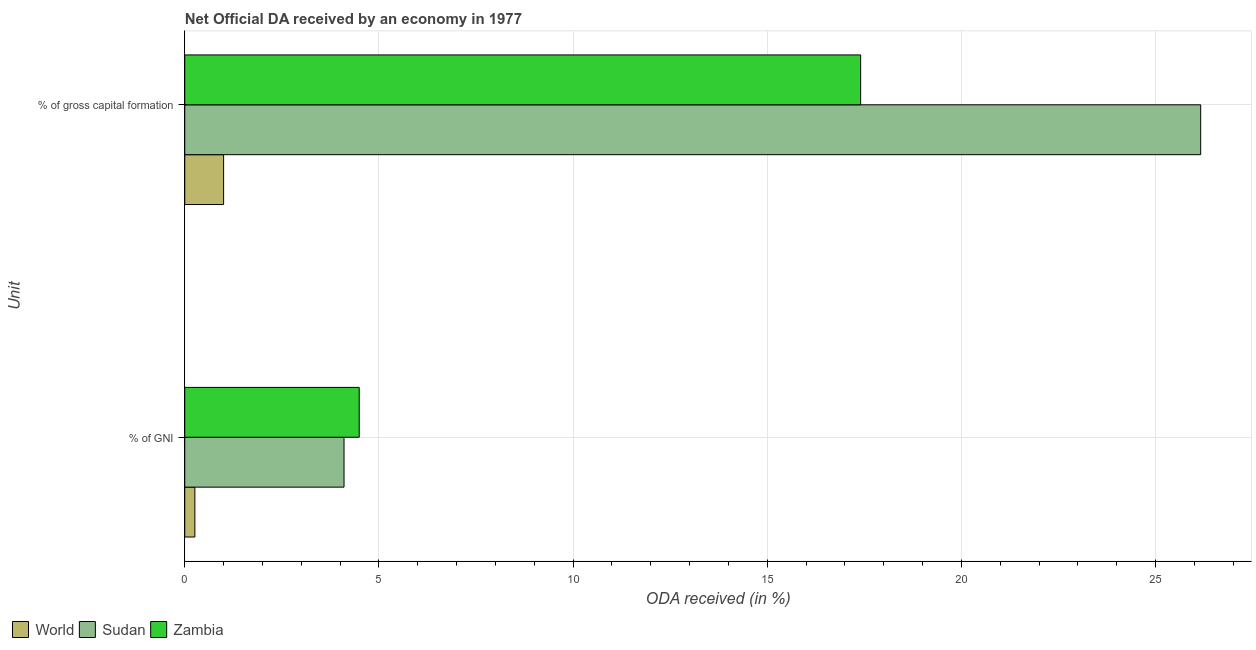How many groups of bars are there?
Your answer should be compact. 2. Are the number of bars on each tick of the Y-axis equal?
Give a very brief answer. Yes. How many bars are there on the 2nd tick from the top?
Ensure brevity in your answer.  3. How many bars are there on the 2nd tick from the bottom?
Your response must be concise. 3. What is the label of the 2nd group of bars from the top?
Provide a short and direct response. % of GNI. What is the oda received as percentage of gross capital formation in Zambia?
Provide a succinct answer. 17.4. Across all countries, what is the maximum oda received as percentage of gni?
Provide a succinct answer. 4.49. Across all countries, what is the minimum oda received as percentage of gross capital formation?
Offer a terse response. 1. In which country was the oda received as percentage of gni maximum?
Provide a succinct answer. Zambia. In which country was the oda received as percentage of gni minimum?
Your answer should be very brief. World. What is the total oda received as percentage of gross capital formation in the graph?
Provide a succinct answer. 44.57. What is the difference between the oda received as percentage of gni in Zambia and that in World?
Your answer should be compact. 4.23. What is the difference between the oda received as percentage of gross capital formation in World and the oda received as percentage of gni in Sudan?
Your answer should be very brief. -3.1. What is the average oda received as percentage of gni per country?
Your response must be concise. 2.95. What is the difference between the oda received as percentage of gni and oda received as percentage of gross capital formation in Zambia?
Offer a very short reply. -12.91. In how many countries, is the oda received as percentage of gross capital formation greater than 14 %?
Offer a very short reply. 2. What is the ratio of the oda received as percentage of gni in Sudan to that in World?
Provide a succinct answer. 15.73. In how many countries, is the oda received as percentage of gross capital formation greater than the average oda received as percentage of gross capital formation taken over all countries?
Keep it short and to the point. 2. What does the 3rd bar from the bottom in % of GNI represents?
Offer a very short reply. Zambia. How many countries are there in the graph?
Your response must be concise. 3. What is the difference between two consecutive major ticks on the X-axis?
Your answer should be compact. 5. Are the values on the major ticks of X-axis written in scientific E-notation?
Provide a short and direct response. No. Does the graph contain any zero values?
Ensure brevity in your answer.  No. How many legend labels are there?
Provide a succinct answer. 3. How are the legend labels stacked?
Make the answer very short. Horizontal. What is the title of the graph?
Ensure brevity in your answer.  Net Official DA received by an economy in 1977. Does "Samoa" appear as one of the legend labels in the graph?
Provide a short and direct response. No. What is the label or title of the X-axis?
Give a very brief answer. ODA received (in %). What is the label or title of the Y-axis?
Provide a short and direct response. Unit. What is the ODA received (in %) in World in % of GNI?
Your answer should be compact. 0.26. What is the ODA received (in %) in Sudan in % of GNI?
Provide a succinct answer. 4.1. What is the ODA received (in %) in Zambia in % of GNI?
Offer a very short reply. 4.49. What is the ODA received (in %) of World in % of gross capital formation?
Offer a terse response. 1. What is the ODA received (in %) in Sudan in % of gross capital formation?
Make the answer very short. 26.16. What is the ODA received (in %) of Zambia in % of gross capital formation?
Keep it short and to the point. 17.4. Across all Unit, what is the maximum ODA received (in %) of World?
Your response must be concise. 1. Across all Unit, what is the maximum ODA received (in %) in Sudan?
Your answer should be very brief. 26.16. Across all Unit, what is the maximum ODA received (in %) of Zambia?
Offer a terse response. 17.4. Across all Unit, what is the minimum ODA received (in %) of World?
Ensure brevity in your answer.  0.26. Across all Unit, what is the minimum ODA received (in %) in Sudan?
Your answer should be compact. 4.1. Across all Unit, what is the minimum ODA received (in %) of Zambia?
Offer a terse response. 4.49. What is the total ODA received (in %) in World in the graph?
Give a very brief answer. 1.26. What is the total ODA received (in %) in Sudan in the graph?
Offer a very short reply. 30.26. What is the total ODA received (in %) in Zambia in the graph?
Offer a very short reply. 21.9. What is the difference between the ODA received (in %) of World in % of GNI and that in % of gross capital formation?
Provide a succinct answer. -0.74. What is the difference between the ODA received (in %) in Sudan in % of GNI and that in % of gross capital formation?
Make the answer very short. -22.06. What is the difference between the ODA received (in %) of Zambia in % of GNI and that in % of gross capital formation?
Give a very brief answer. -12.91. What is the difference between the ODA received (in %) of World in % of GNI and the ODA received (in %) of Sudan in % of gross capital formation?
Your answer should be compact. -25.9. What is the difference between the ODA received (in %) in World in % of GNI and the ODA received (in %) in Zambia in % of gross capital formation?
Provide a succinct answer. -17.14. What is the difference between the ODA received (in %) in Sudan in % of GNI and the ODA received (in %) in Zambia in % of gross capital formation?
Offer a very short reply. -13.3. What is the average ODA received (in %) of World per Unit?
Offer a very short reply. 0.63. What is the average ODA received (in %) in Sudan per Unit?
Keep it short and to the point. 15.13. What is the average ODA received (in %) of Zambia per Unit?
Give a very brief answer. 10.95. What is the difference between the ODA received (in %) in World and ODA received (in %) in Sudan in % of GNI?
Your answer should be compact. -3.84. What is the difference between the ODA received (in %) of World and ODA received (in %) of Zambia in % of GNI?
Your response must be concise. -4.23. What is the difference between the ODA received (in %) in Sudan and ODA received (in %) in Zambia in % of GNI?
Keep it short and to the point. -0.39. What is the difference between the ODA received (in %) of World and ODA received (in %) of Sudan in % of gross capital formation?
Offer a very short reply. -25.16. What is the difference between the ODA received (in %) in World and ODA received (in %) in Zambia in % of gross capital formation?
Make the answer very short. -16.4. What is the difference between the ODA received (in %) of Sudan and ODA received (in %) of Zambia in % of gross capital formation?
Your response must be concise. 8.76. What is the ratio of the ODA received (in %) of World in % of GNI to that in % of gross capital formation?
Your answer should be compact. 0.26. What is the ratio of the ODA received (in %) in Sudan in % of GNI to that in % of gross capital formation?
Provide a succinct answer. 0.16. What is the ratio of the ODA received (in %) in Zambia in % of GNI to that in % of gross capital formation?
Keep it short and to the point. 0.26. What is the difference between the highest and the second highest ODA received (in %) of World?
Ensure brevity in your answer.  0.74. What is the difference between the highest and the second highest ODA received (in %) of Sudan?
Your response must be concise. 22.06. What is the difference between the highest and the second highest ODA received (in %) of Zambia?
Offer a very short reply. 12.91. What is the difference between the highest and the lowest ODA received (in %) in World?
Provide a short and direct response. 0.74. What is the difference between the highest and the lowest ODA received (in %) of Sudan?
Provide a succinct answer. 22.06. What is the difference between the highest and the lowest ODA received (in %) of Zambia?
Offer a terse response. 12.91. 